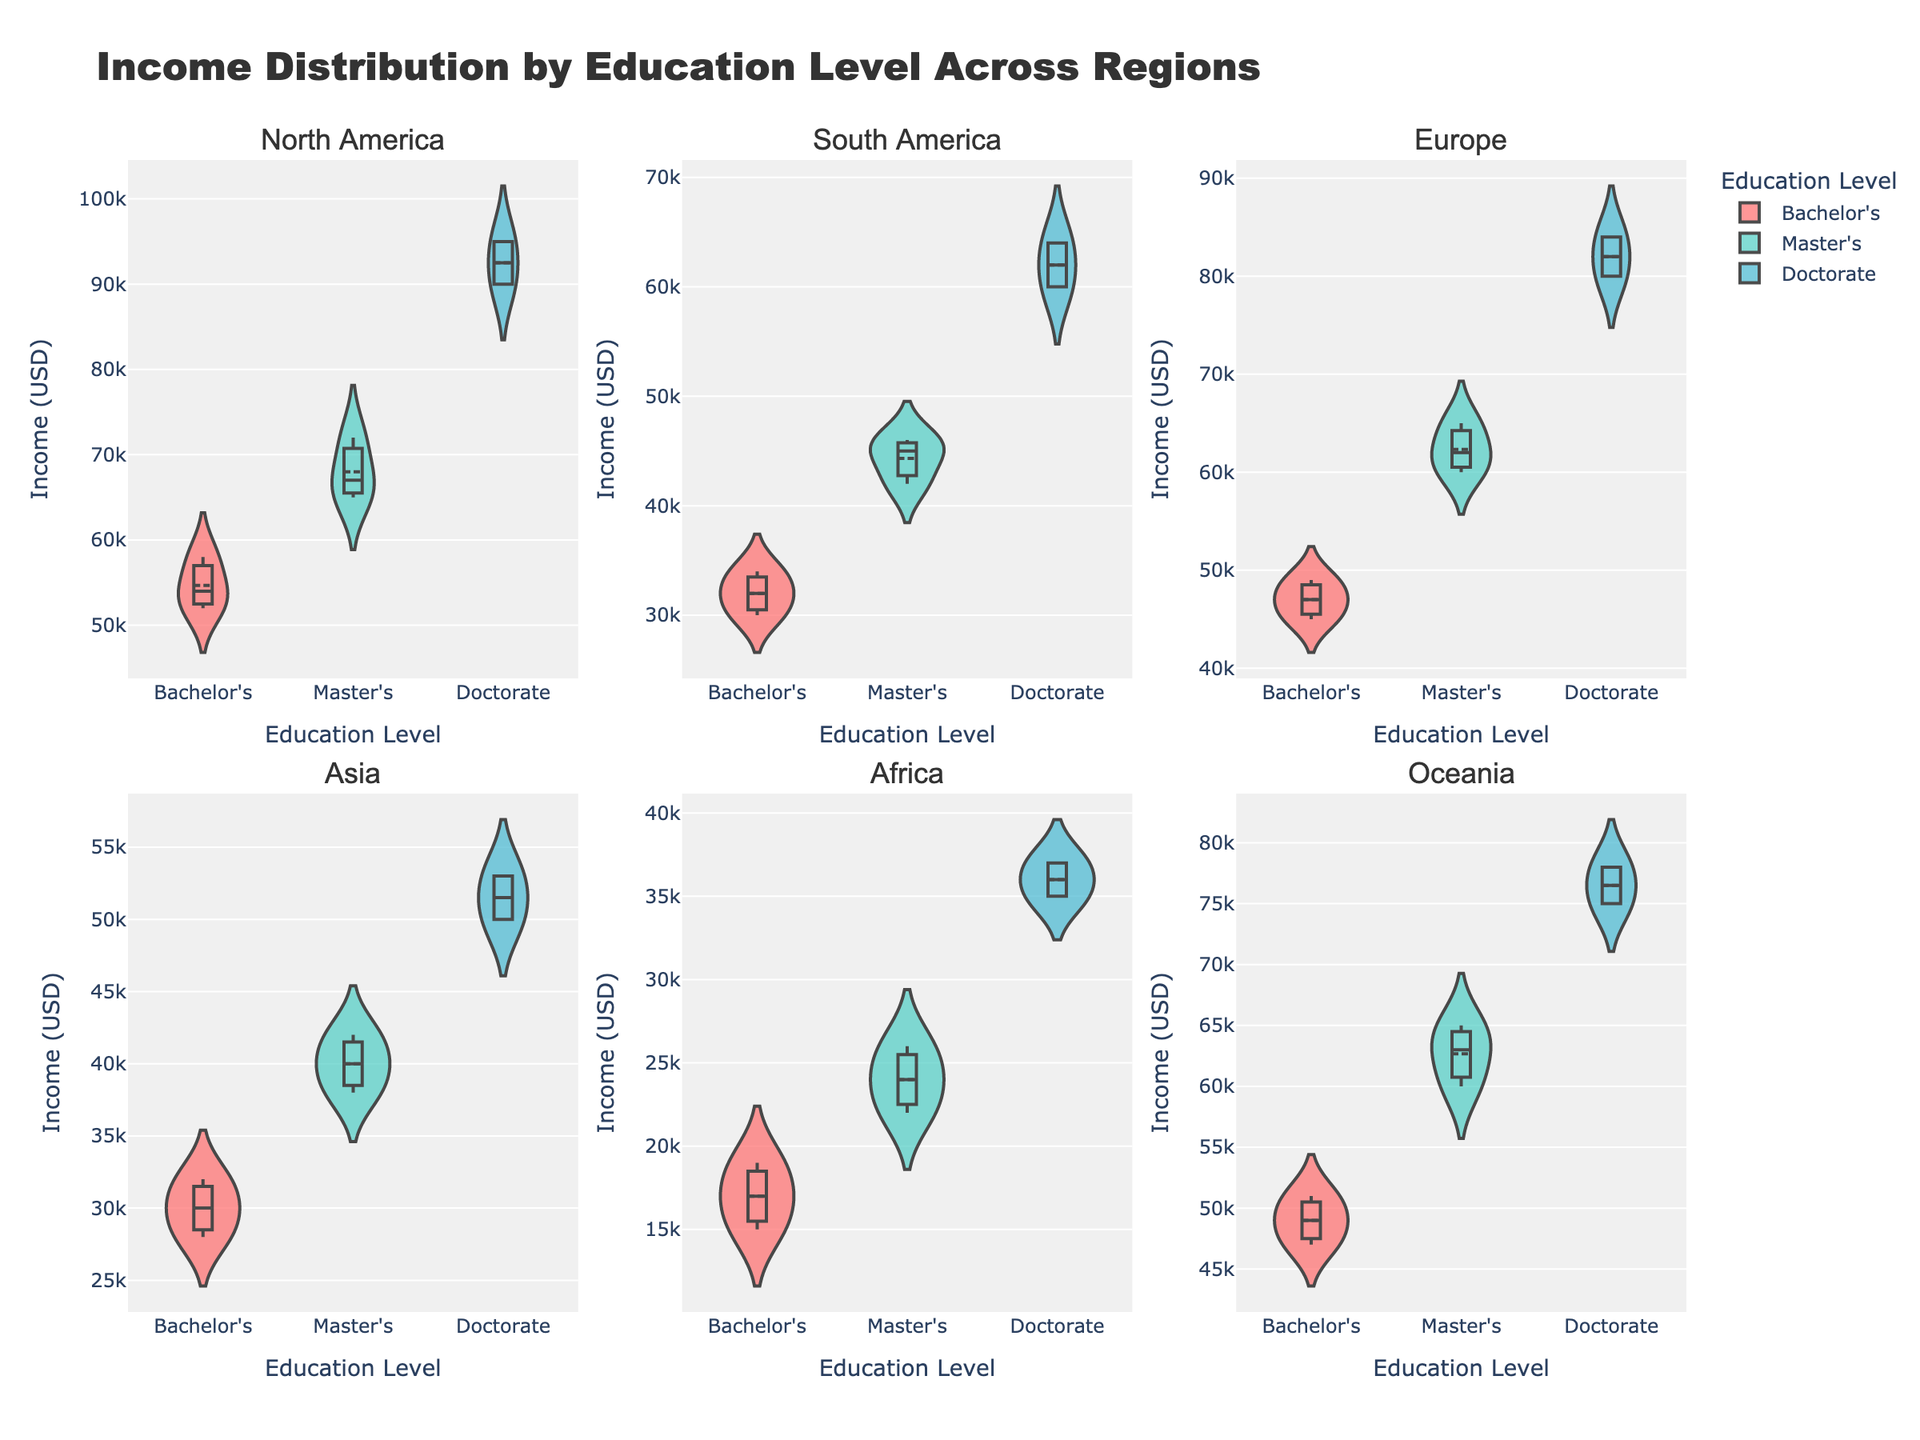what is the title of the figure? The title of the figure is stated at the top of the plot and reads: "Income Distribution by Education Level Across Regions". This is a basic information request concerning the overall plot title.
Answer: Income Distribution by Education Level Across Regions Which region has the highest median income for Bachelor's degree holders? The median income can be observed by looking at the horizontal line inside the violin plots. For Bachelor's degree holders, the highest median income is in North America as indicated by the position of the median line.
Answer: North America How does the range of incomes for Doctorate degree holders in South America compare to that in North America? The range of incomes is illustrated by the width of the violin plot. South America's Doctorate holders have incomes ranging from 60000 to 64000, while North America's range is from 90000 to 95000. North America has a higher income range.
Answer: North America has a higher income range What is the mean income for Master's degree holders in Europe? The mean income can be noted by the line inside the violin plot. Observing the violin charts in Europe for Master's degrees, the mean income line is approximately at 62000.
Answer: 62000 Which region shows the most variability in income for Doctorate degree holders? Variability in income can be gauged by the spread of the violin plot. For Doctorate degree holders, North America shows the most variability as indicated by the wider spread of the plot compared to other regions.
Answer: North America Are there any regions where Master's degree holders earn more than Doctorate degree holders? By comparing the position of the median lines in the violin plots for Master's and Doctorate degree holders across all regions, no region shows Master's degree holders earning more than Doctorate degree holders.
Answer: No What’s the income range for Bachelor's degree holders in Africa? The range can be observed from the bottom to the top of the violin plot for Bachelor's degree holders in Africa. The income range is from 15000 to 19000.
Answer: 15000 to 19000 Which education level in Asia has the narrowest income distribution? The narrowest distribution can be seen by identifying the narrowest violin plot. In Asia, the Bachelor's degree holders have the narrowest distribution, shown by the less spread-out violin plot.
Answer: Bachelor's Which region has the highest maximum income for Master's degree holders? The highest maximum income for Master's degree holders can be found by comparing the top-most point of the violin plots across all regions. North America exhibits the highest maximum income.
Answer: North America 